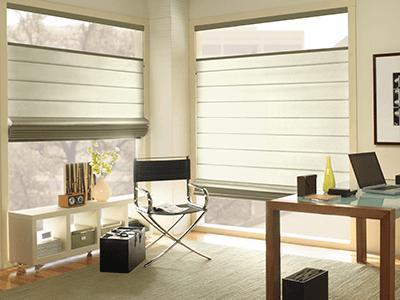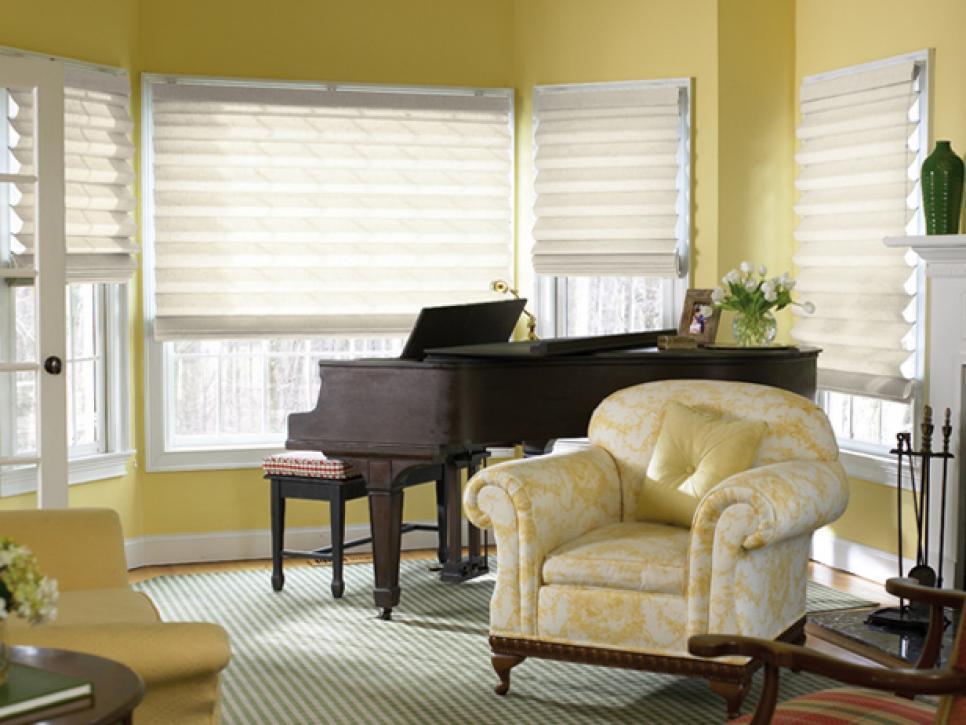The first image is the image on the left, the second image is the image on the right. For the images shown, is this caption "A room features a table on a rug in front of a couch, which is in front of windows with three colored shades." true? Answer yes or no. No. The first image is the image on the left, the second image is the image on the right. Given the left and right images, does the statement "Each image shows three blinds covering three windows side-by-side on the same wall." hold true? Answer yes or no. No. 